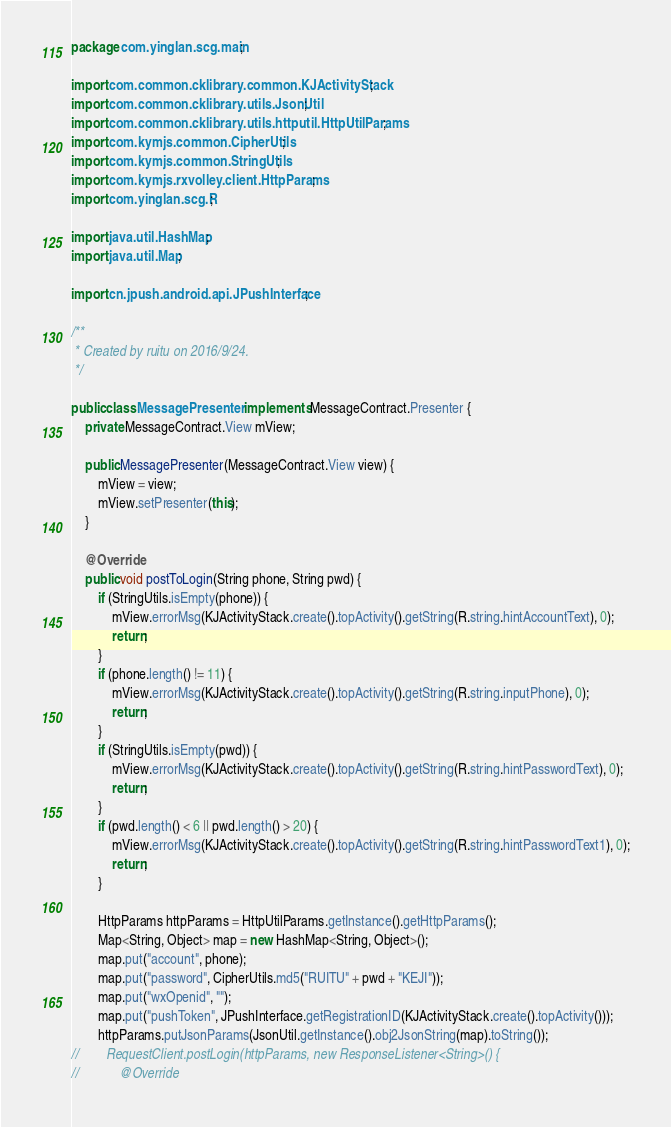Convert code to text. <code><loc_0><loc_0><loc_500><loc_500><_Java_>package com.yinglan.scg.main;

import com.common.cklibrary.common.KJActivityStack;
import com.common.cklibrary.utils.JsonUtil;
import com.common.cklibrary.utils.httputil.HttpUtilParams;
import com.kymjs.common.CipherUtils;
import com.kymjs.common.StringUtils;
import com.kymjs.rxvolley.client.HttpParams;
import com.yinglan.scg.R;

import java.util.HashMap;
import java.util.Map;

import cn.jpush.android.api.JPushInterface;

/**
 * Created by ruitu on 2016/9/24.
 */

public class MessagePresenter implements MessageContract.Presenter {
    private MessageContract.View mView;

    public MessagePresenter(MessageContract.View view) {
        mView = view;
        mView.setPresenter(this);
    }

    @Override
    public void postToLogin(String phone, String pwd) {
        if (StringUtils.isEmpty(phone)) {
            mView.errorMsg(KJActivityStack.create().topActivity().getString(R.string.hintAccountText), 0);
            return;
        }
        if (phone.length() != 11) {
            mView.errorMsg(KJActivityStack.create().topActivity().getString(R.string.inputPhone), 0);
            return;
        }
        if (StringUtils.isEmpty(pwd)) {
            mView.errorMsg(KJActivityStack.create().topActivity().getString(R.string.hintPasswordText), 0);
            return;
        }
        if (pwd.length() < 6 || pwd.length() > 20) {
            mView.errorMsg(KJActivityStack.create().topActivity().getString(R.string.hintPasswordText1), 0);
            return;
        }

        HttpParams httpParams = HttpUtilParams.getInstance().getHttpParams();
        Map<String, Object> map = new HashMap<String, Object>();
        map.put("account", phone);
        map.put("password", CipherUtils.md5("RUITU" + pwd + "KEJI"));
        map.put("wxOpenid", "");
        map.put("pushToken", JPushInterface.getRegistrationID(KJActivityStack.create().topActivity()));
        httpParams.putJsonParams(JsonUtil.getInstance().obj2JsonString(map).toString());
//        RequestClient.postLogin(httpParams, new ResponseListener<String>() {
//            @Override</code> 